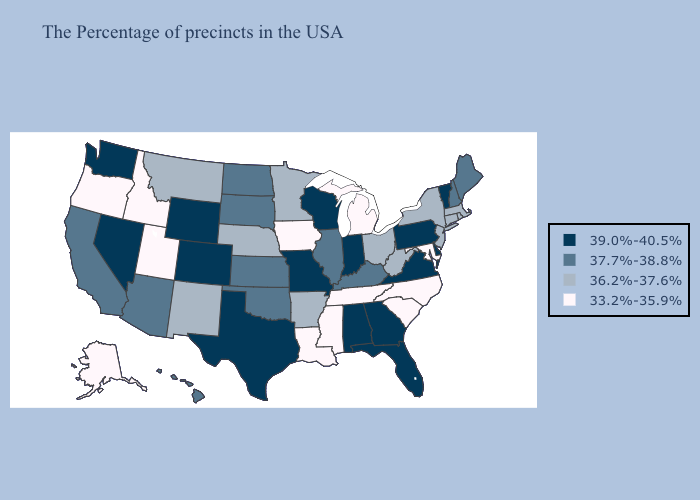Does Oregon have a higher value than Utah?
Keep it brief. No. Name the states that have a value in the range 33.2%-35.9%?
Quick response, please. Maryland, North Carolina, South Carolina, Michigan, Tennessee, Mississippi, Louisiana, Iowa, Utah, Idaho, Oregon, Alaska. What is the highest value in states that border Iowa?
Keep it brief. 39.0%-40.5%. Does Rhode Island have the highest value in the Northeast?
Answer briefly. No. Does Ohio have the same value as New York?
Be succinct. Yes. Among the states that border Wyoming , does South Dakota have the lowest value?
Be succinct. No. What is the lowest value in states that border South Carolina?
Keep it brief. 33.2%-35.9%. Does Wyoming have the highest value in the USA?
Answer briefly. Yes. What is the value of Pennsylvania?
Quick response, please. 39.0%-40.5%. Among the states that border North Dakota , does Minnesota have the lowest value?
Keep it brief. Yes. Name the states that have a value in the range 37.7%-38.8%?
Give a very brief answer. Maine, New Hampshire, Kentucky, Illinois, Kansas, Oklahoma, South Dakota, North Dakota, Arizona, California, Hawaii. What is the lowest value in states that border Nevada?
Give a very brief answer. 33.2%-35.9%. Does Kentucky have a higher value than Maryland?
Quick response, please. Yes. Which states have the lowest value in the South?
Give a very brief answer. Maryland, North Carolina, South Carolina, Tennessee, Mississippi, Louisiana. Which states hav the highest value in the Northeast?
Be succinct. Vermont, Pennsylvania. 